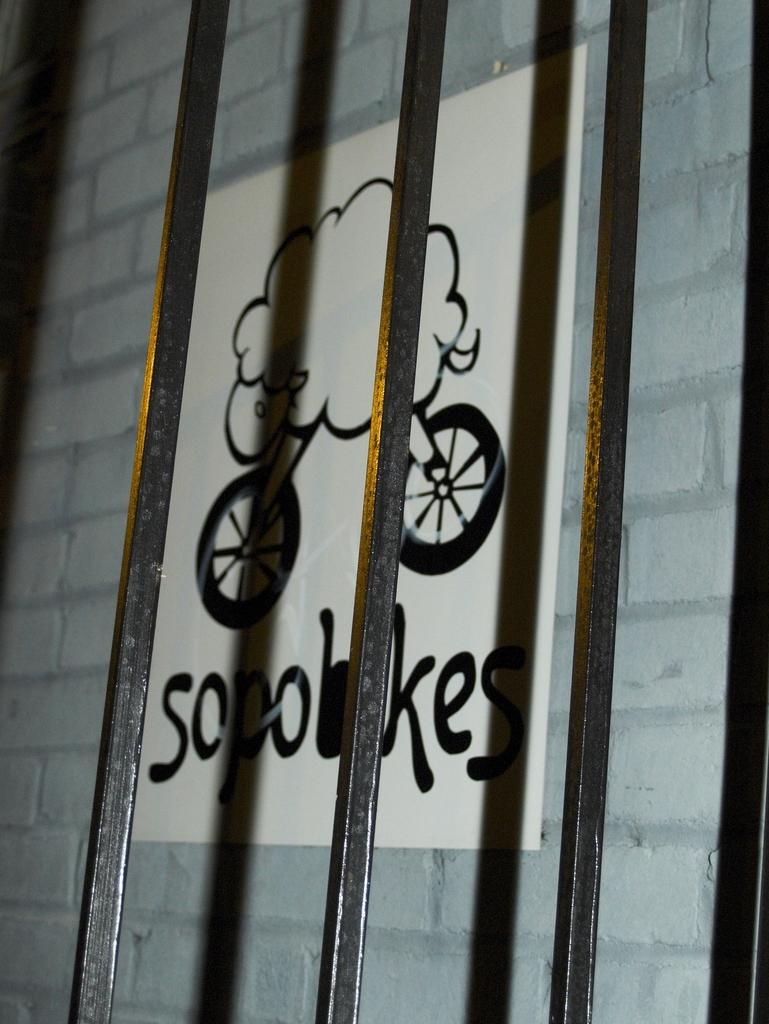What objects are located in the middle of the image? There are three metal rods in the middle of the image. What can be seen in the background of the image? There is a poster with text on the wall in the background of the image. What type of soap is being used to clean the furniture in the image? There is no soap or furniture present in the image; it only features three metal rods and a poster with text on the wall. 